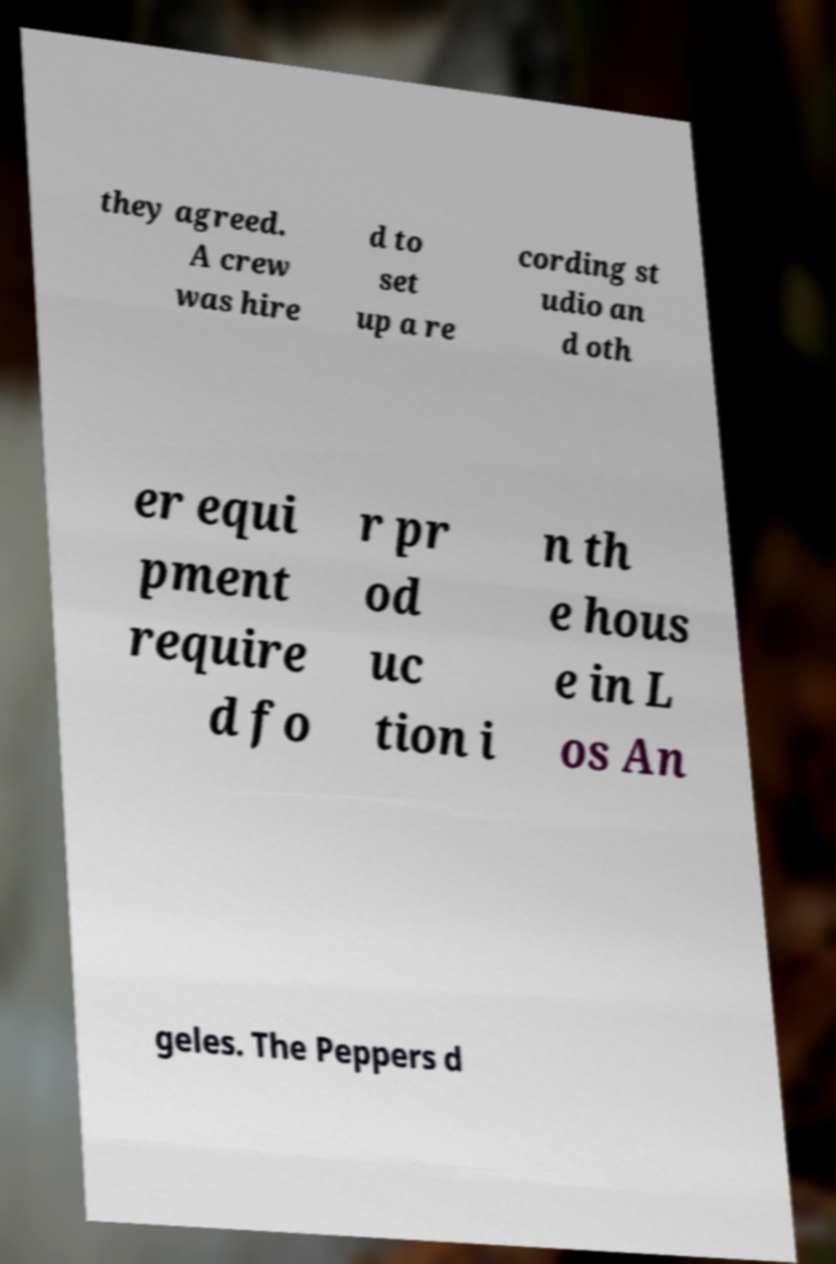Can you accurately transcribe the text from the provided image for me? they agreed. A crew was hire d to set up a re cording st udio an d oth er equi pment require d fo r pr od uc tion i n th e hous e in L os An geles. The Peppers d 